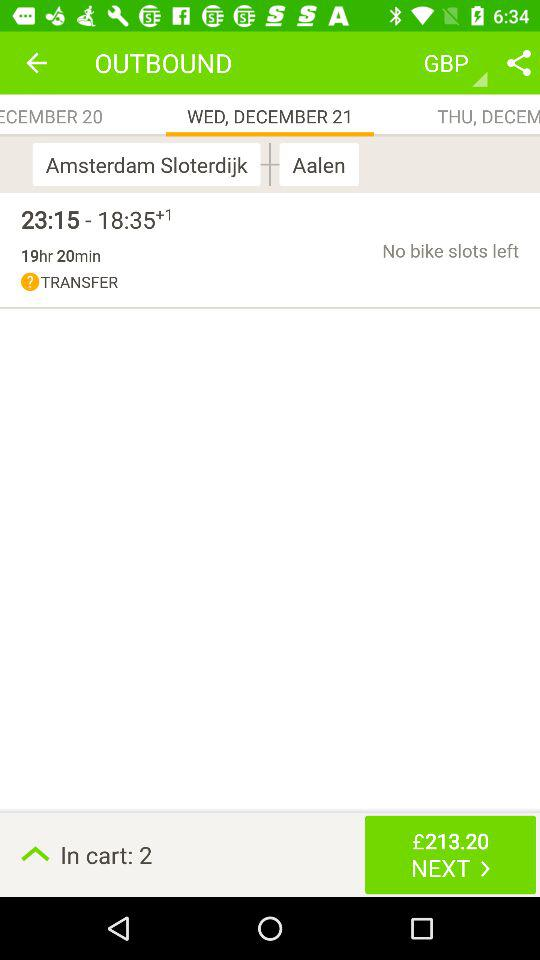What is the selected option? The selected options are "GBP" and "WED, DECEMBER 21". 